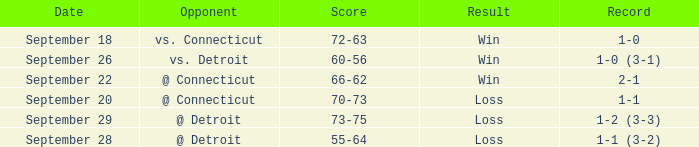WHAT IS THE OPPONENT WITH A SCORE OF 72-63? Vs. connecticut. 